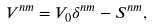Convert formula to latex. <formula><loc_0><loc_0><loc_500><loc_500>V ^ { n m } = V _ { 0 } \delta ^ { n m } - S ^ { n m } ,</formula> 